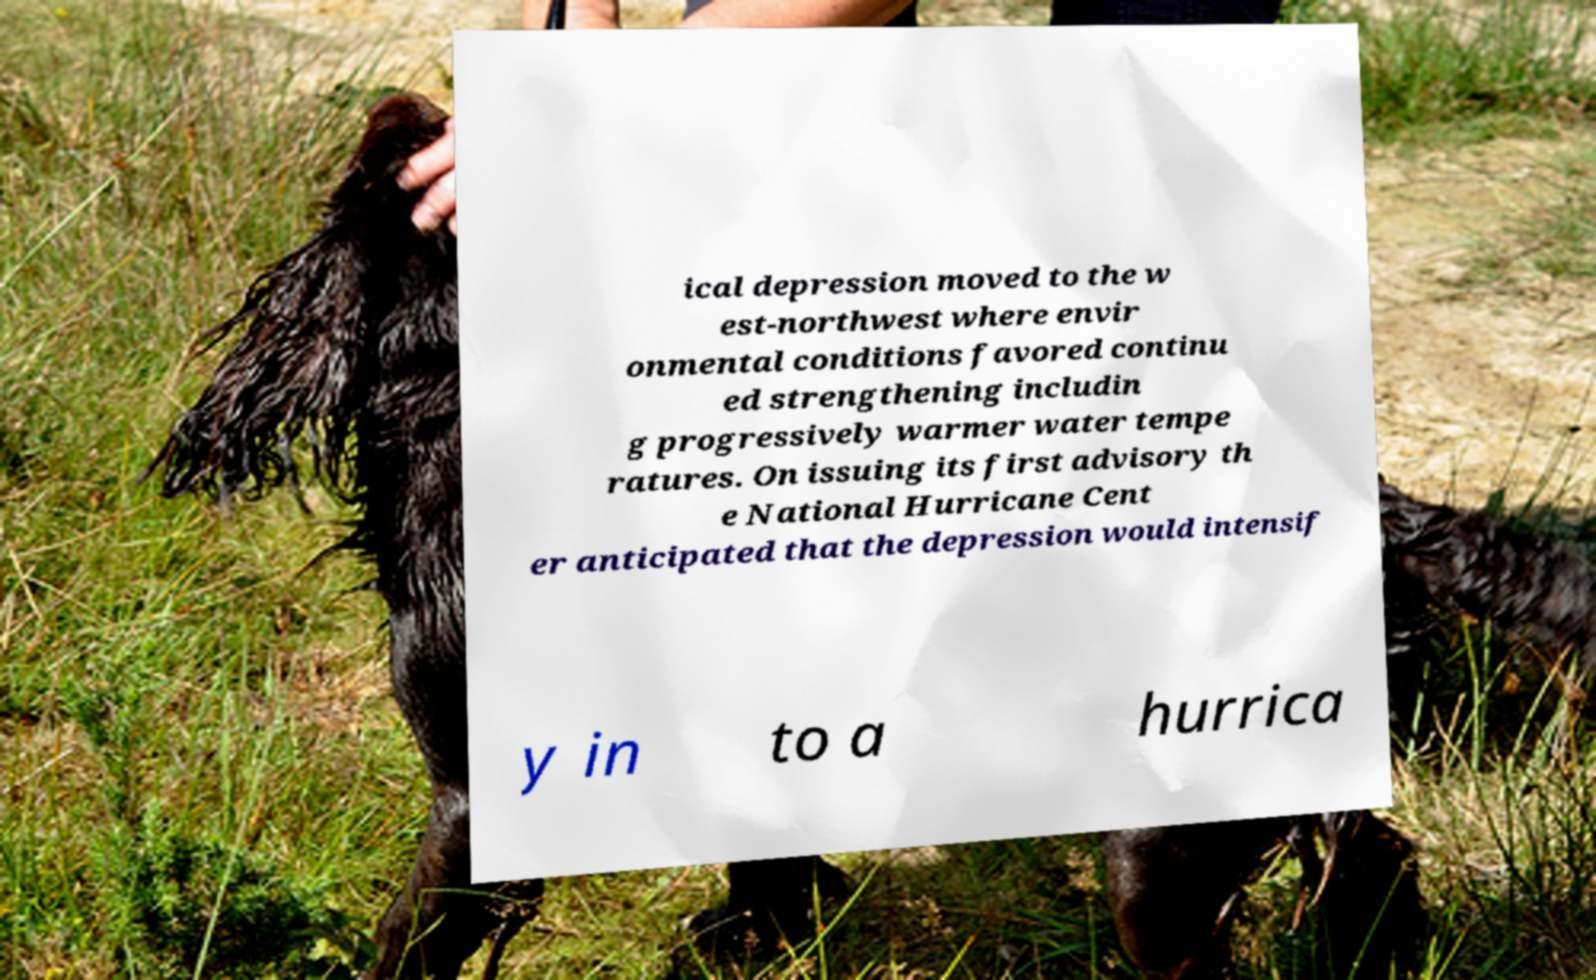Could you assist in decoding the text presented in this image and type it out clearly? ical depression moved to the w est-northwest where envir onmental conditions favored continu ed strengthening includin g progressively warmer water tempe ratures. On issuing its first advisory th e National Hurricane Cent er anticipated that the depression would intensif y in to a hurrica 